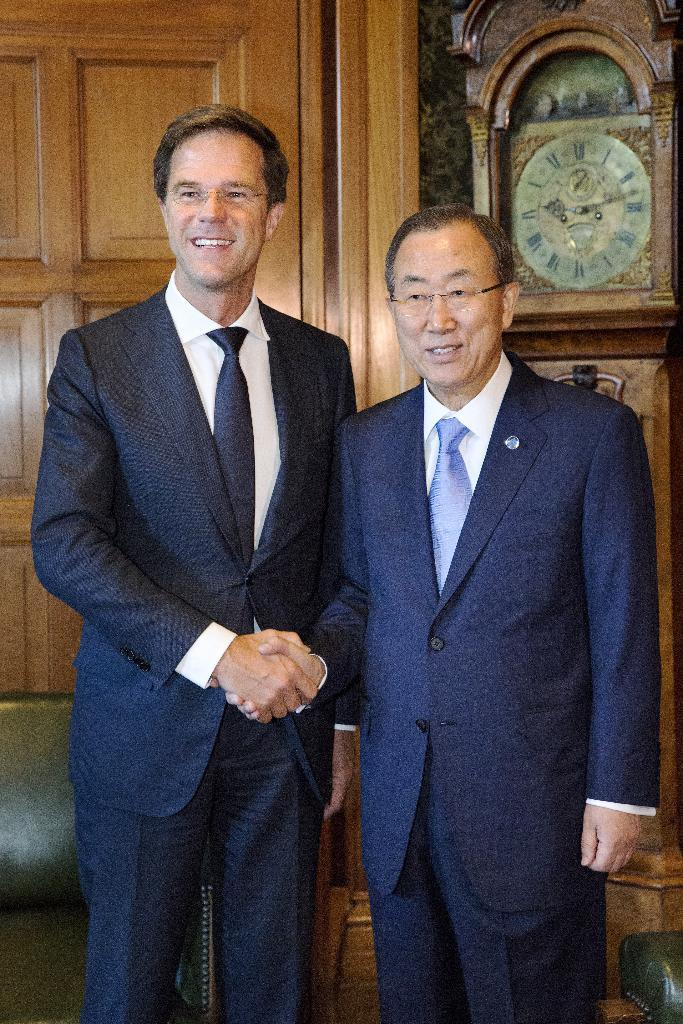How many people are in the image? There are two men in the image. What are the men doing in the image? The men are standing and shaking hands. What is the emotional expression of the men in the image? The men are smiling in the image. What type of window can be seen in the image? There is a wooden window in the image. Where is the wooden window located in the image? The wooden window is part of a wall. What time-keeping device is present in the image? There is a clock in the image. Where is the clock located in relation to the men? The clock is located to the right of the men. What type of fruit is the men eating in the image? There is no fruit present in the image, and the men are not shown eating anything. What activity is the pear participating in with the men? There is no pear present in the image, and therefore no such activity can be observed. 